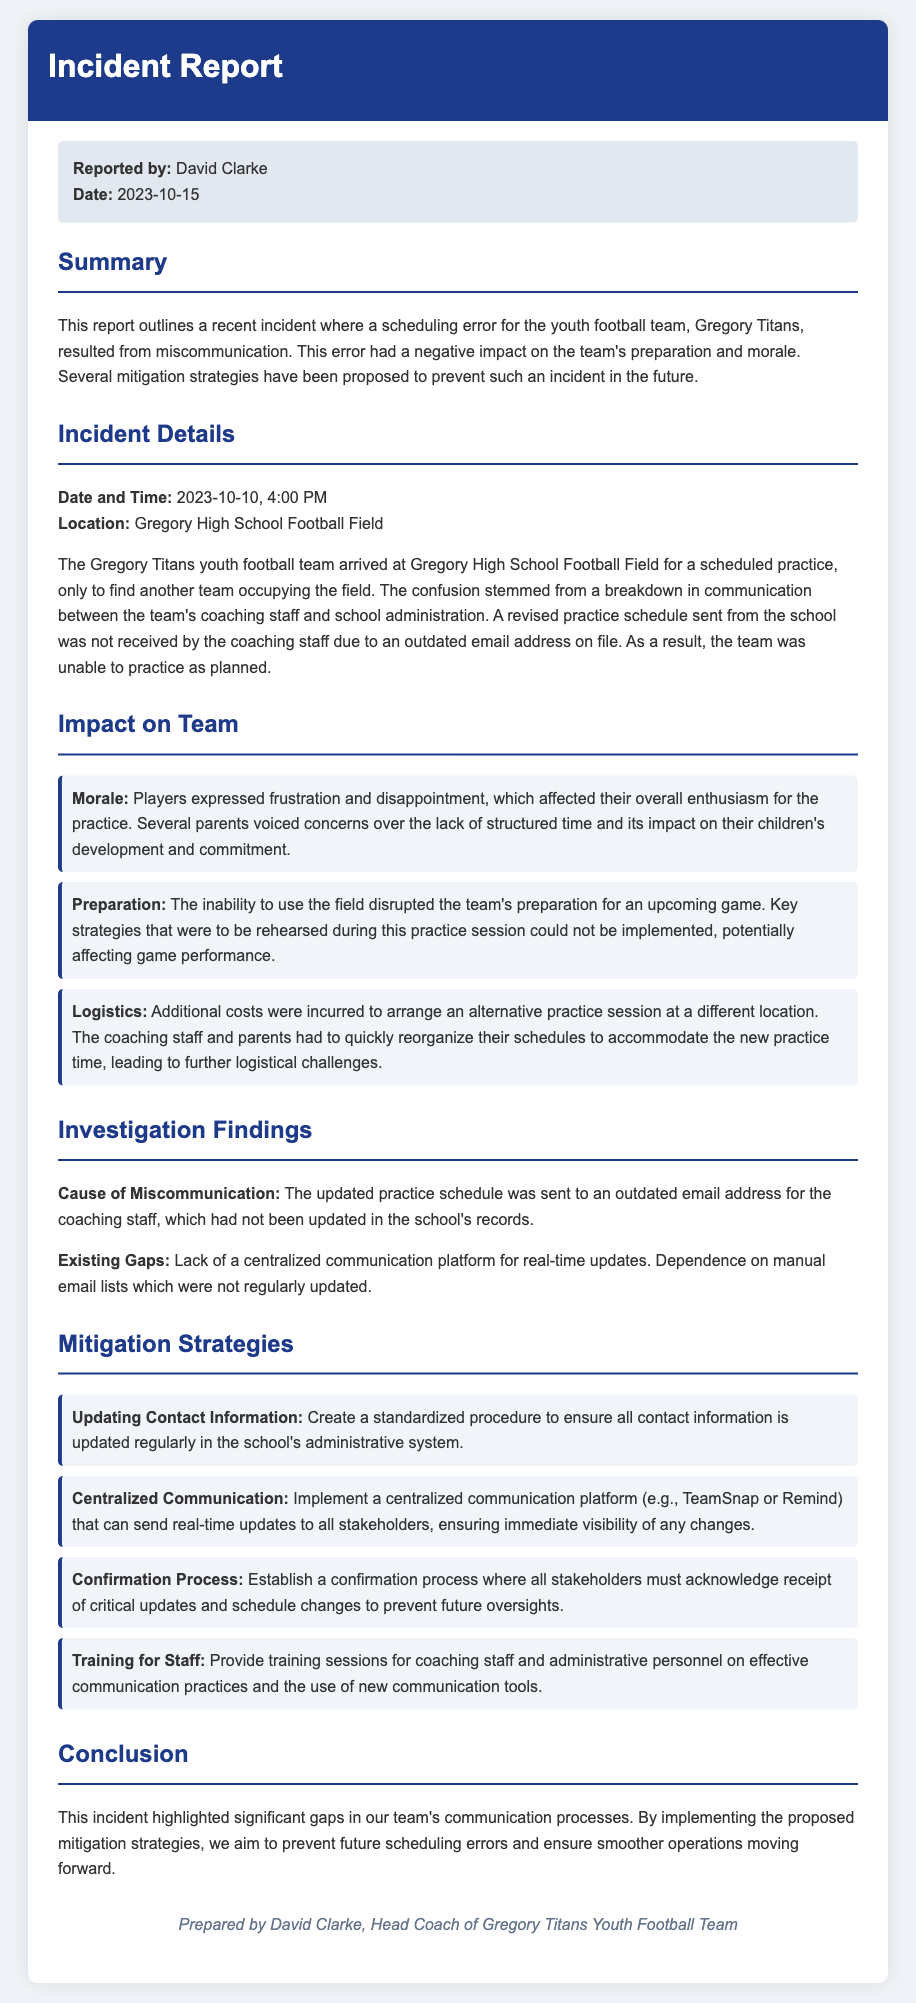what is the date of the incident? The date of the incident is specified in the incident details section of the report.
Answer: 2023-10-10 who reported the incident? The report clearly states the name of the individual who prepared and reported the incident.
Answer: David Clarke what was the scheduled time for the practice? The scheduled time is directly mentioned in the incident details section.
Answer: 4:00 PM what is one impact on team morale? The impact on team morale is discussed in the impact section and reflects on players' feelings.
Answer: Frustration what was the cause of the miscommunication? The cause is detailed in the investigation findings section of the report.
Answer: Outdated email address what is one proposed mitigation strategy? The report lists several strategies and one can be selected from that section.
Answer: Updating Contact Information how much time was lost due to the incident? The report implies disruption but does not explicitly state a time duration; hence this question may require summarizing information.
Answer: The exact duration is not specified what was the location of the incident? The location is explicitly mentioned in the incident details section.
Answer: Gregory High School Football Field what did the coaching staff lack that contributed to the incident? The existing gaps mentioned indicate a major gap in communication methods.
Answer: Centralized communication platform 